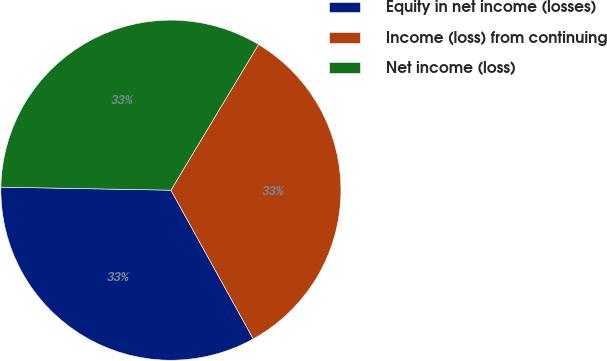<chart> <loc_0><loc_0><loc_500><loc_500><pie_chart><fcel>Equity in net income (losses)<fcel>Income (loss) from continuing<fcel>Net income (loss)<nl><fcel>33.33%<fcel>33.33%<fcel>33.33%<nl></chart> 